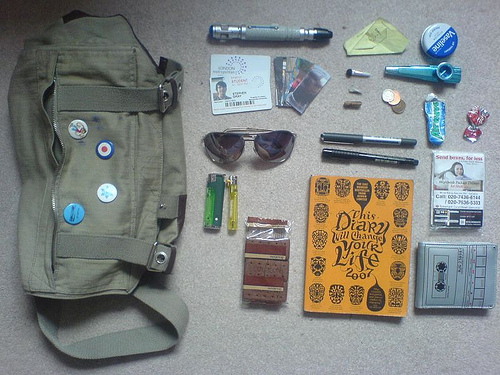<image>
Can you confirm if the marker is on the floor? Yes. Looking at the image, I can see the marker is positioned on top of the floor, with the floor providing support. 